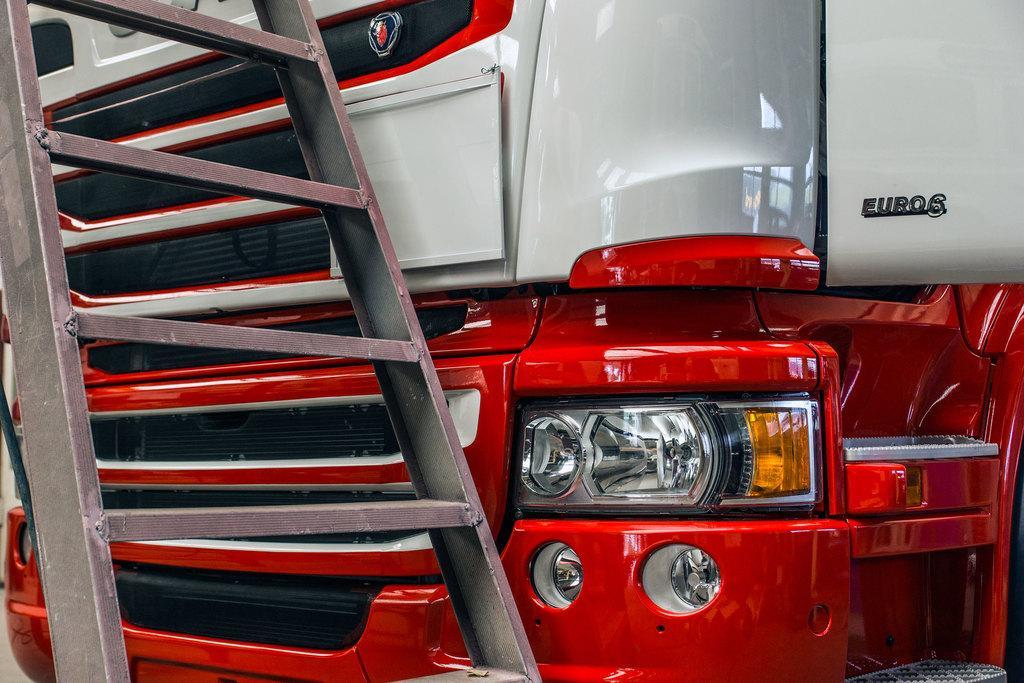How would you summarize this image in a sentence or two? In this picture I can see a ladder and there is a front part of a vehicle. 